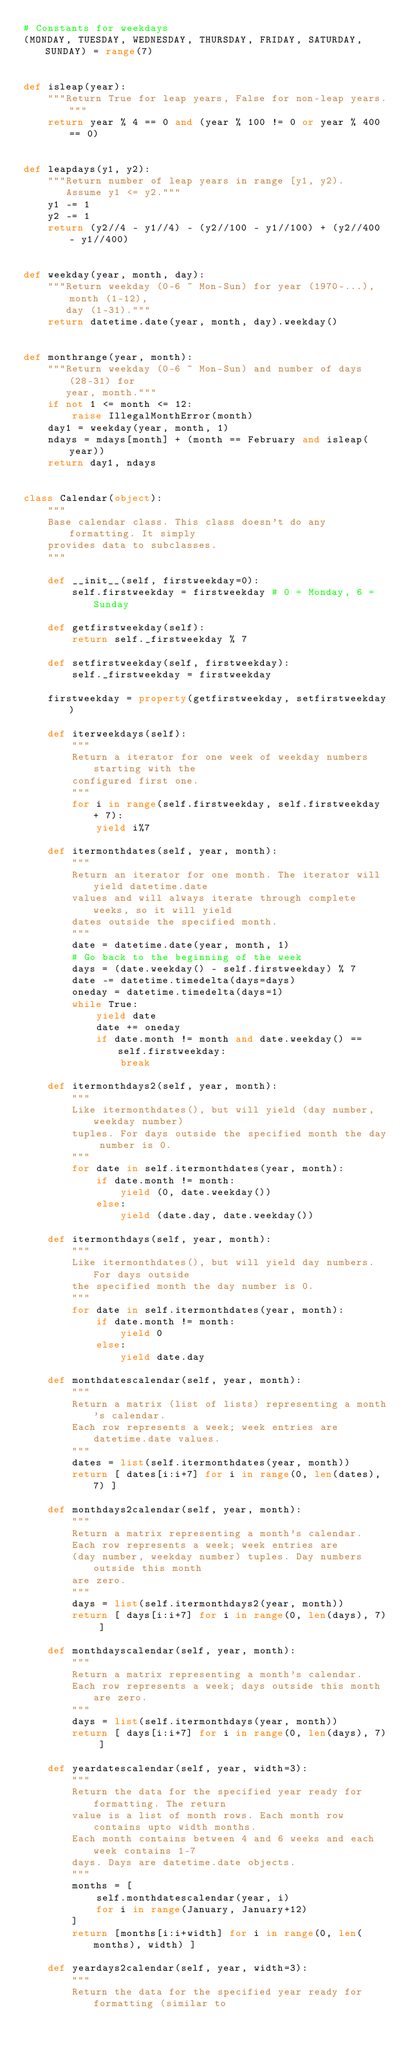<code> <loc_0><loc_0><loc_500><loc_500><_Python_># Constants for weekdays
(MONDAY, TUESDAY, WEDNESDAY, THURSDAY, FRIDAY, SATURDAY, SUNDAY) = range(7)


def isleap(year):
    """Return True for leap years, False for non-leap years."""
    return year % 4 == 0 and (year % 100 != 0 or year % 400 == 0)


def leapdays(y1, y2):
    """Return number of leap years in range [y1, y2).
       Assume y1 <= y2."""
    y1 -= 1
    y2 -= 1
    return (y2//4 - y1//4) - (y2//100 - y1//100) + (y2//400 - y1//400)


def weekday(year, month, day):
    """Return weekday (0-6 ~ Mon-Sun) for year (1970-...), month (1-12),
       day (1-31)."""
    return datetime.date(year, month, day).weekday()


def monthrange(year, month):
    """Return weekday (0-6 ~ Mon-Sun) and number of days (28-31) for
       year, month."""
    if not 1 <= month <= 12:
        raise IllegalMonthError(month)
    day1 = weekday(year, month, 1)
    ndays = mdays[month] + (month == February and isleap(year))
    return day1, ndays


class Calendar(object):
    """
    Base calendar class. This class doesn't do any formatting. It simply
    provides data to subclasses.
    """

    def __init__(self, firstweekday=0):
        self.firstweekday = firstweekday # 0 = Monday, 6 = Sunday

    def getfirstweekday(self):
        return self._firstweekday % 7

    def setfirstweekday(self, firstweekday):
        self._firstweekday = firstweekday

    firstweekday = property(getfirstweekday, setfirstweekday)

    def iterweekdays(self):
        """
        Return a iterator for one week of weekday numbers starting with the
        configured first one.
        """
        for i in range(self.firstweekday, self.firstweekday + 7):
            yield i%7

    def itermonthdates(self, year, month):
        """
        Return an iterator for one month. The iterator will yield datetime.date
        values and will always iterate through complete weeks, so it will yield
        dates outside the specified month.
        """
        date = datetime.date(year, month, 1)
        # Go back to the beginning of the week
        days = (date.weekday() - self.firstweekday) % 7
        date -= datetime.timedelta(days=days)
        oneday = datetime.timedelta(days=1)
        while True:
            yield date
            date += oneday
            if date.month != month and date.weekday() == self.firstweekday:
                break

    def itermonthdays2(self, year, month):
        """
        Like itermonthdates(), but will yield (day number, weekday number)
        tuples. For days outside the specified month the day number is 0.
        """
        for date in self.itermonthdates(year, month):
            if date.month != month:
                yield (0, date.weekday())
            else:
                yield (date.day, date.weekday())

    def itermonthdays(self, year, month):
        """
        Like itermonthdates(), but will yield day numbers. For days outside
        the specified month the day number is 0.
        """
        for date in self.itermonthdates(year, month):
            if date.month != month:
                yield 0
            else:
                yield date.day

    def monthdatescalendar(self, year, month):
        """
        Return a matrix (list of lists) representing a month's calendar.
        Each row represents a week; week entries are datetime.date values.
        """
        dates = list(self.itermonthdates(year, month))
        return [ dates[i:i+7] for i in range(0, len(dates), 7) ]

    def monthdays2calendar(self, year, month):
        """
        Return a matrix representing a month's calendar.
        Each row represents a week; week entries are
        (day number, weekday number) tuples. Day numbers outside this month
        are zero.
        """
        days = list(self.itermonthdays2(year, month))
        return [ days[i:i+7] for i in range(0, len(days), 7) ]

    def monthdayscalendar(self, year, month):
        """
        Return a matrix representing a month's calendar.
        Each row represents a week; days outside this month are zero.
        """
        days = list(self.itermonthdays(year, month))
        return [ days[i:i+7] for i in range(0, len(days), 7) ]

    def yeardatescalendar(self, year, width=3):
        """
        Return the data for the specified year ready for formatting. The return
        value is a list of month rows. Each month row contains upto width months.
        Each month contains between 4 and 6 weeks and each week contains 1-7
        days. Days are datetime.date objects.
        """
        months = [
            self.monthdatescalendar(year, i)
            for i in range(January, January+12)
        ]
        return [months[i:i+width] for i in range(0, len(months), width) ]

    def yeardays2calendar(self, year, width=3):
        """
        Return the data for the specified year ready for formatting (similar to</code> 